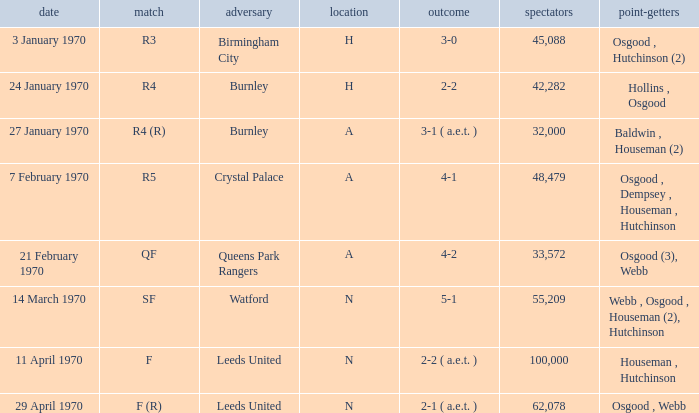What round was the game against Watford? SF. 